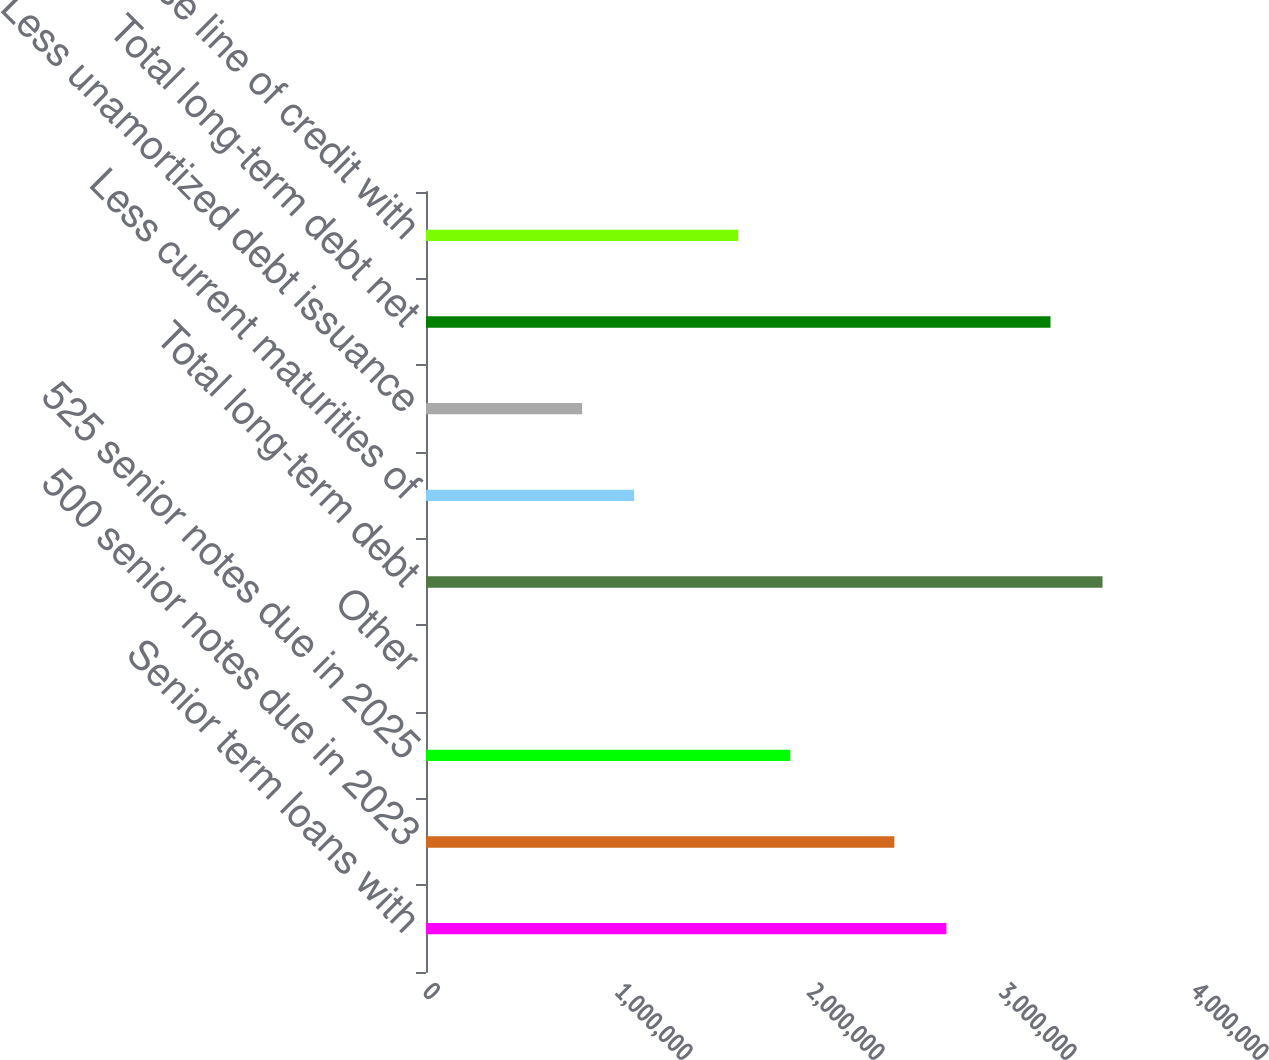Convert chart to OTSL. <chart><loc_0><loc_0><loc_500><loc_500><bar_chart><fcel>Senior term loans with<fcel>500 senior notes due in 2023<fcel>525 senior notes due in 2025<fcel>Other<fcel>Total long-term debt<fcel>Less current maturities of<fcel>Less unamortized debt issuance<fcel>Total long-term debt net<fcel>Warehouse line of credit with<nl><fcel>2.71044e+06<fcel>2.4394e+06<fcel>1.89733e+06<fcel>63<fcel>3.52355e+06<fcel>1.08421e+06<fcel>813176<fcel>3.25251e+06<fcel>1.62629e+06<nl></chart> 